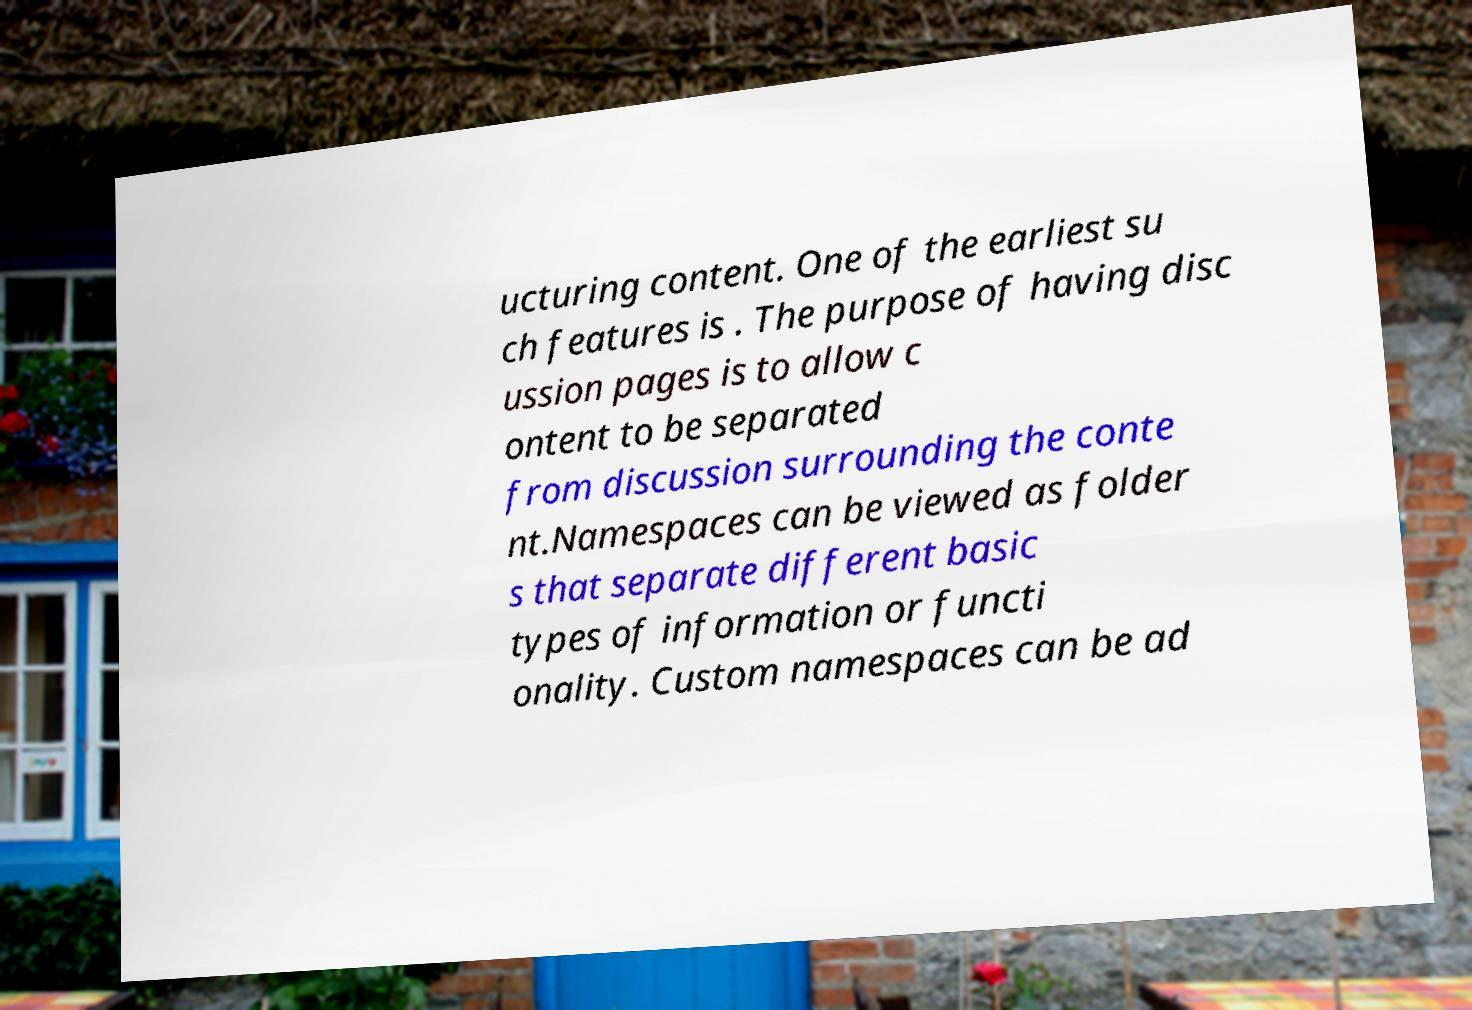I need the written content from this picture converted into text. Can you do that? ucturing content. One of the earliest su ch features is . The purpose of having disc ussion pages is to allow c ontent to be separated from discussion surrounding the conte nt.Namespaces can be viewed as folder s that separate different basic types of information or functi onality. Custom namespaces can be ad 